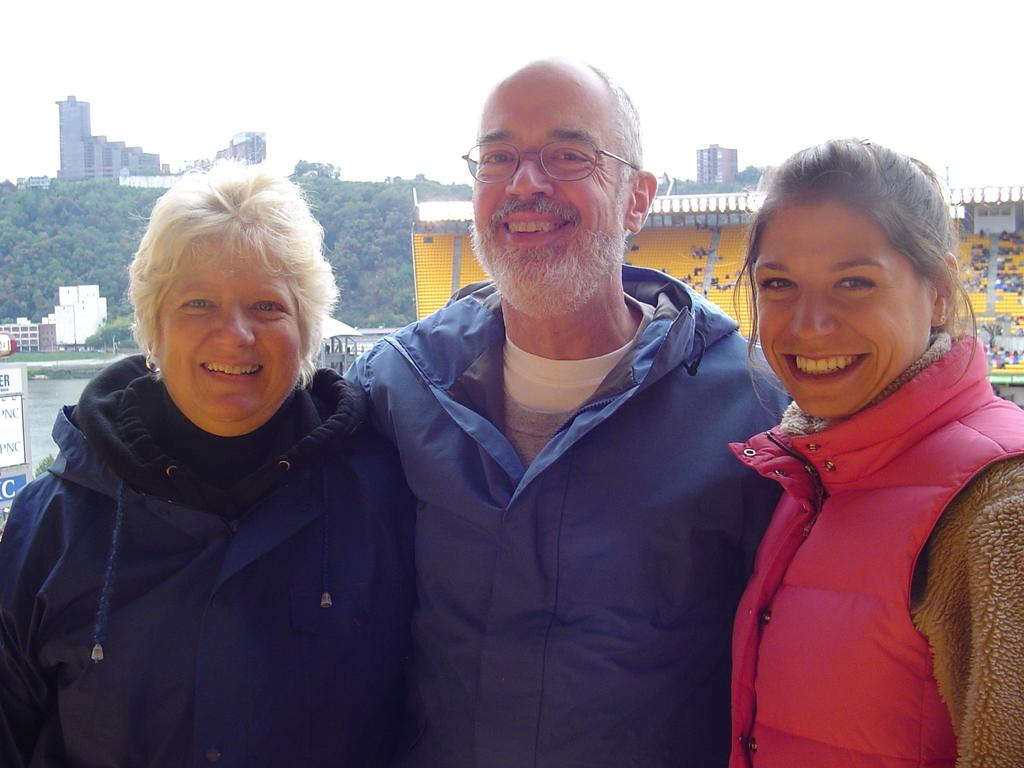How many people are in the image? There are three persons standing in the image. Where are the persons located in the image? The persons are at the bottom of the image. What can be seen in the background of the image? There are trees and buildings in the background of the image. What is visible at the top of the image? The sky is visible at the top of the image. What type of sound can be heard coming from the maid in the image? There is no maid present in the image, so it's not possible to determine what sound might be heard. 